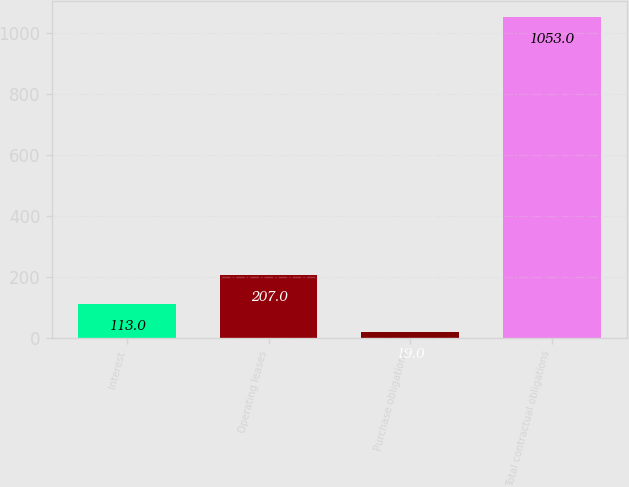Convert chart to OTSL. <chart><loc_0><loc_0><loc_500><loc_500><bar_chart><fcel>Interest<fcel>Operating leases<fcel>Purchase obligations<fcel>Total contractual obligations<nl><fcel>113<fcel>207<fcel>19<fcel>1053<nl></chart> 